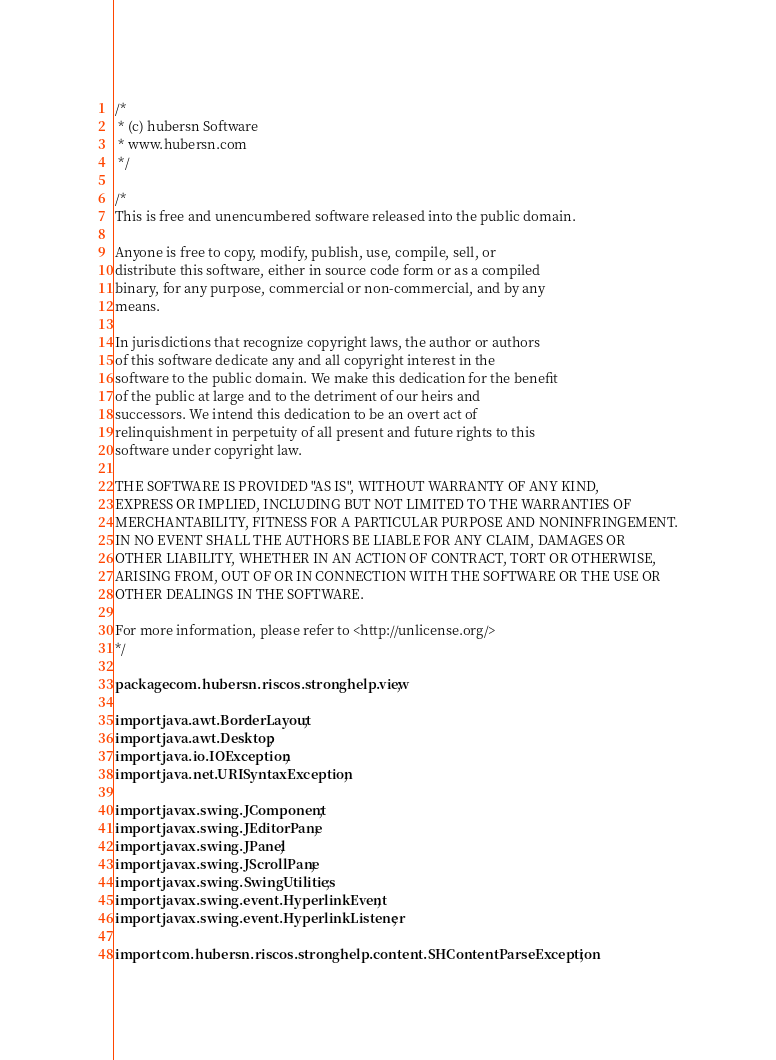Convert code to text. <code><loc_0><loc_0><loc_500><loc_500><_Java_>/*
 * (c) hubersn Software
 * www.hubersn.com
 */

/*
This is free and unencumbered software released into the public domain.

Anyone is free to copy, modify, publish, use, compile, sell, or
distribute this software, either in source code form or as a compiled
binary, for any purpose, commercial or non-commercial, and by any
means.

In jurisdictions that recognize copyright laws, the author or authors
of this software dedicate any and all copyright interest in the
software to the public domain. We make this dedication for the benefit
of the public at large and to the detriment of our heirs and
successors. We intend this dedication to be an overt act of
relinquishment in perpetuity of all present and future rights to this
software under copyright law.

THE SOFTWARE IS PROVIDED "AS IS", WITHOUT WARRANTY OF ANY KIND,
EXPRESS OR IMPLIED, INCLUDING BUT NOT LIMITED TO THE WARRANTIES OF
MERCHANTABILITY, FITNESS FOR A PARTICULAR PURPOSE AND NONINFRINGEMENT.
IN NO EVENT SHALL THE AUTHORS BE LIABLE FOR ANY CLAIM, DAMAGES OR
OTHER LIABILITY, WHETHER IN AN ACTION OF CONTRACT, TORT OR OTHERWISE,
ARISING FROM, OUT OF OR IN CONNECTION WITH THE SOFTWARE OR THE USE OR
OTHER DEALINGS IN THE SOFTWARE.

For more information, please refer to <http://unlicense.org/>
*/

package com.hubersn.riscos.stronghelp.view;

import java.awt.BorderLayout;
import java.awt.Desktop;
import java.io.IOException;
import java.net.URISyntaxException;

import javax.swing.JComponent;
import javax.swing.JEditorPane;
import javax.swing.JPanel;
import javax.swing.JScrollPane;
import javax.swing.SwingUtilities;
import javax.swing.event.HyperlinkEvent;
import javax.swing.event.HyperlinkListener;

import com.hubersn.riscos.stronghelp.content.SHContentParseException;</code> 